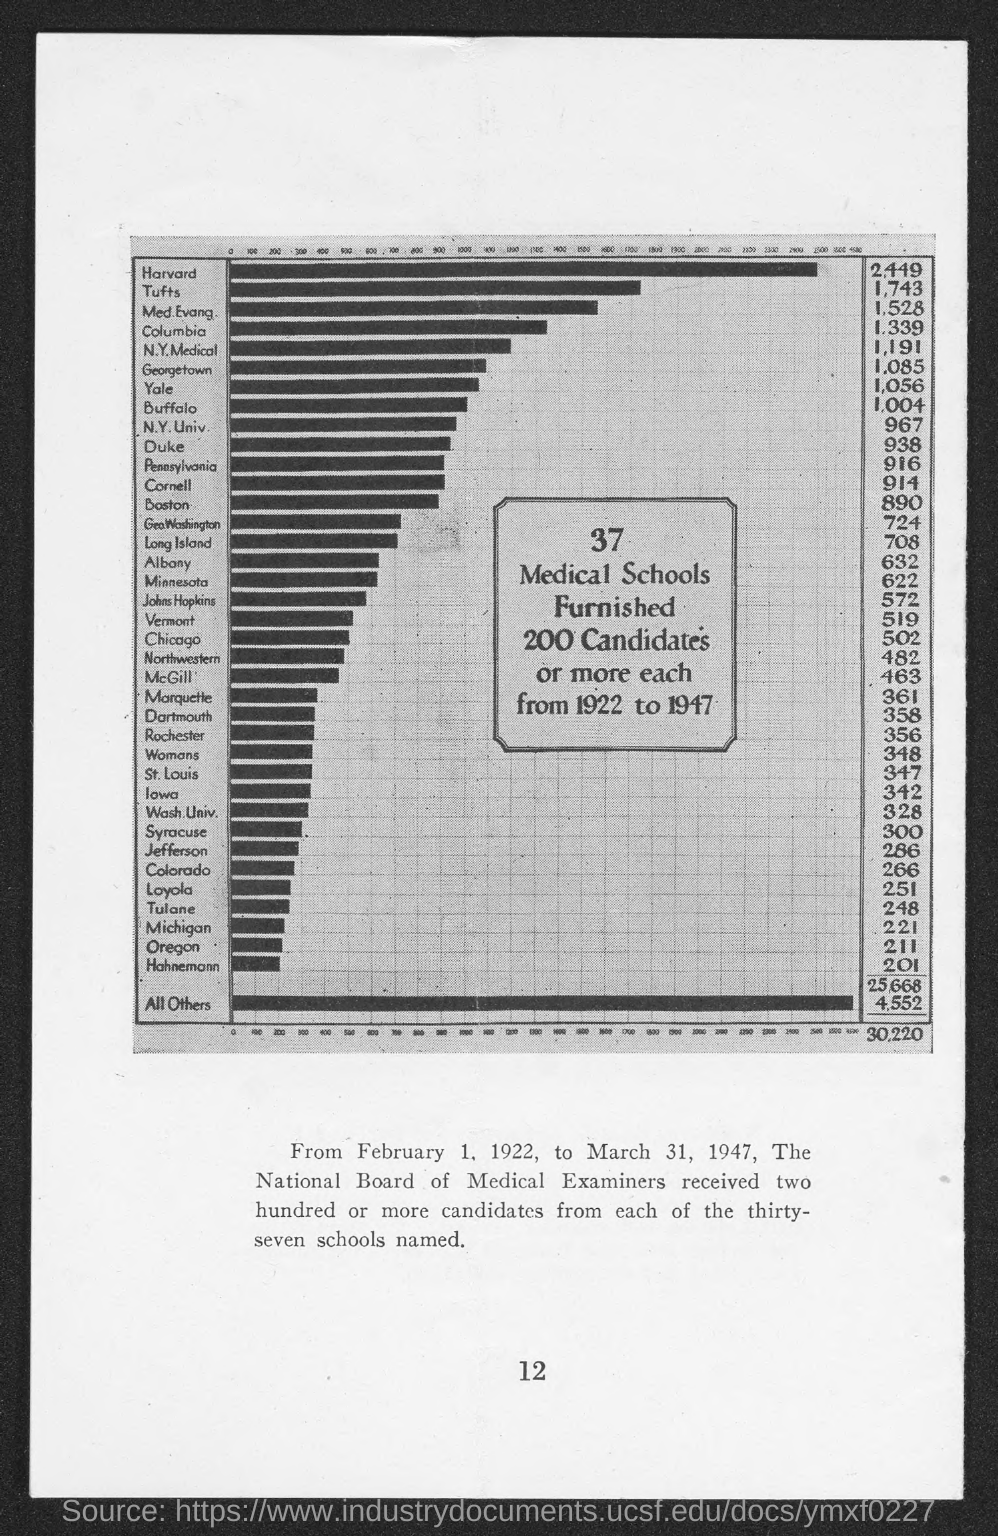Point out several critical features in this image. The number at the bottom of the page is 12. 